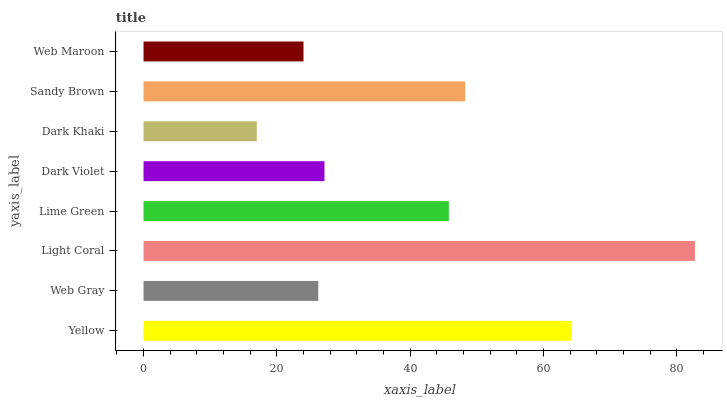Is Dark Khaki the minimum?
Answer yes or no. Yes. Is Light Coral the maximum?
Answer yes or no. Yes. Is Web Gray the minimum?
Answer yes or no. No. Is Web Gray the maximum?
Answer yes or no. No. Is Yellow greater than Web Gray?
Answer yes or no. Yes. Is Web Gray less than Yellow?
Answer yes or no. Yes. Is Web Gray greater than Yellow?
Answer yes or no. No. Is Yellow less than Web Gray?
Answer yes or no. No. Is Lime Green the high median?
Answer yes or no. Yes. Is Dark Violet the low median?
Answer yes or no. Yes. Is Web Gray the high median?
Answer yes or no. No. Is Web Maroon the low median?
Answer yes or no. No. 